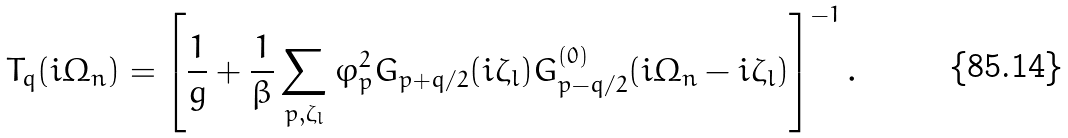Convert formula to latex. <formula><loc_0><loc_0><loc_500><loc_500>T _ { q } ( i \Omega _ { n } ) = \left [ \frac { 1 } { g } + \frac { 1 } { \beta } \sum _ { { p } , \zeta _ { l } } \varphi ^ { 2 } _ { p } G _ { { p + q } / 2 } ( i \zeta _ { l } ) G ^ { ( 0 ) } _ { { p - q } / 2 } ( i \Omega _ { n } - i \zeta _ { l } ) \right ] ^ { - 1 } .</formula> 